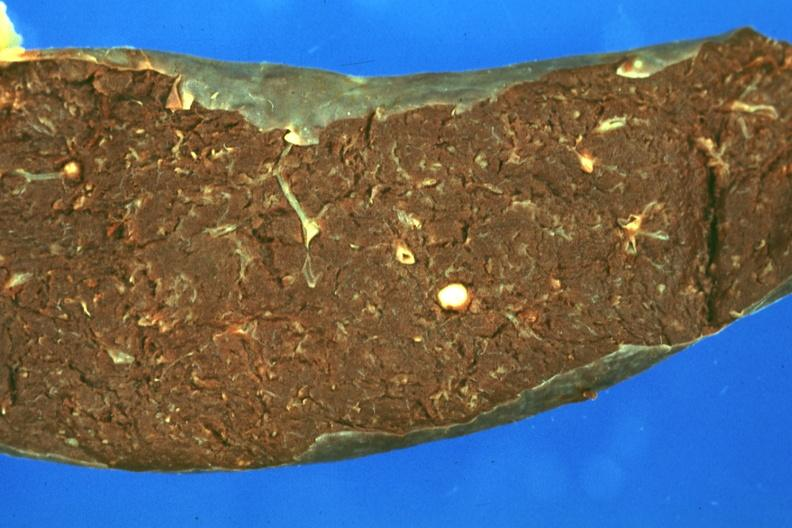where is this part in?
Answer the question using a single word or phrase. Spleen 